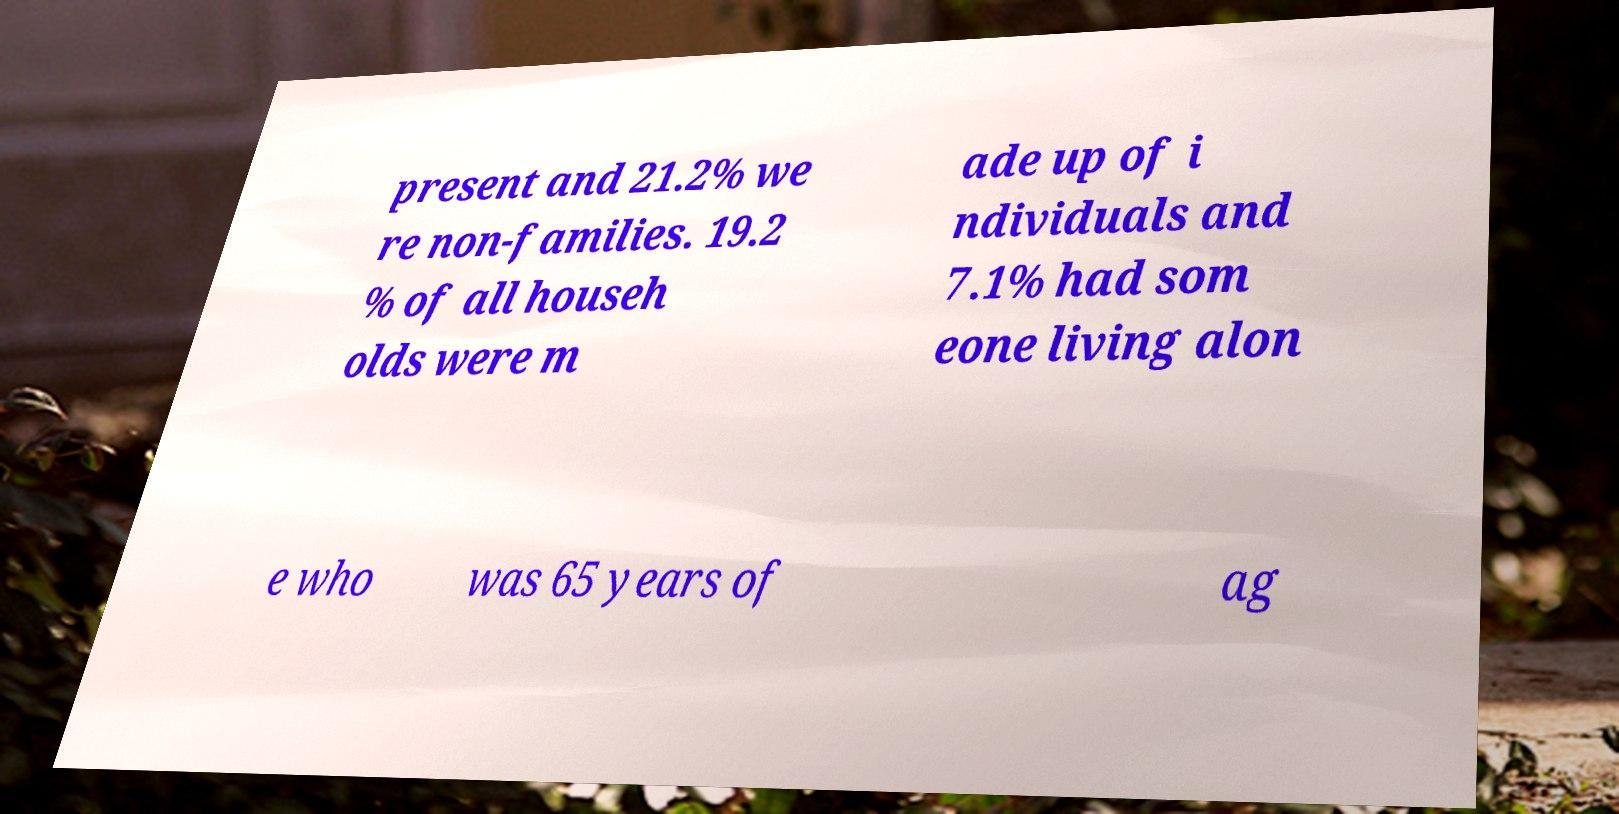Please identify and transcribe the text found in this image. present and 21.2% we re non-families. 19.2 % of all househ olds were m ade up of i ndividuals and 7.1% had som eone living alon e who was 65 years of ag 